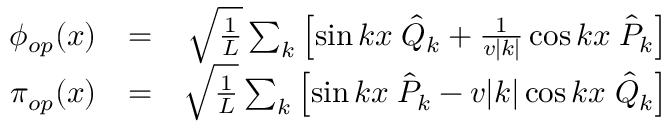Convert formula to latex. <formula><loc_0><loc_0><loc_500><loc_500>\begin{array} { r l r } { \phi _ { o p } ( x ) } & { = } & { \sqrt { \frac { 1 } { L } } \sum _ { k } \left [ \sin k x \, \hat { Q } _ { k } + \frac { 1 } { v | k | } \cos k x \, \hat { P } _ { k } \right ] } \\ { \pi _ { o p } ( x ) } & { = } & { \sqrt { \frac { 1 } { L } } \sum _ { k } \left [ \sin k x \, \hat { P } _ { k } - v | k | \cos k x \, \hat { Q } _ { k } \right ] } \end{array}</formula> 